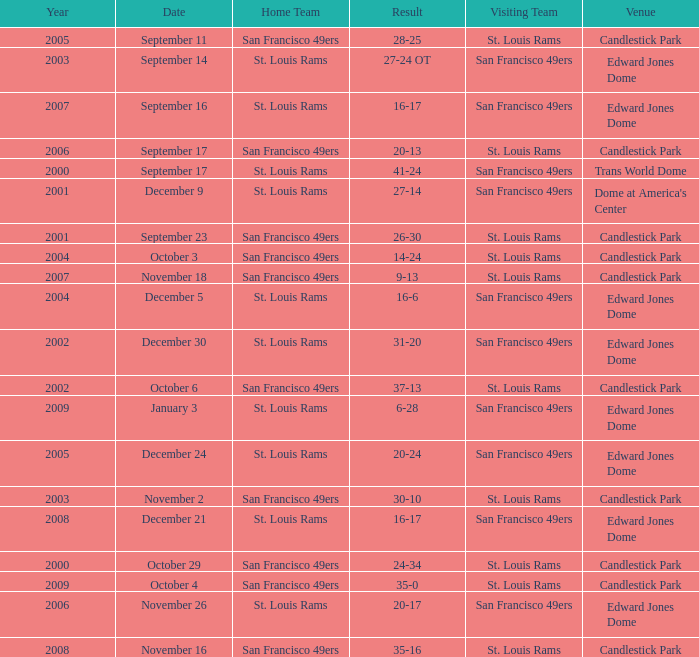What was the Venue of the San Francisco 49ers Home game with a Result of 30-10? Candlestick Park. 